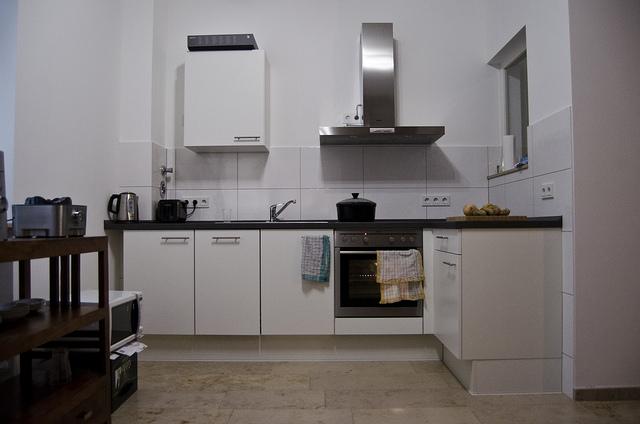Are cabinet doors open?
Keep it brief. No. Are the tiles on the floor all pointing the same direction?
Be succinct. Yes. Is the fridge in the kitchen?
Quick response, please. No. Is this a marble floor?
Give a very brief answer. No. Where is the Coffee pot?
Be succinct. Counter. Is there a door in this room?
Quick response, please. No. Is the pot on the stove?
Keep it brief. Yes. Is this an a very old home?
Give a very brief answer. No. Is it daytime?
Answer briefly. Yes. What fruits are by the sink?
Short answer required. Bananas. How many handles are visible?
Give a very brief answer. 6. Is there anything on the refrigerator door?
Concise answer only. No. What color is the table?
Write a very short answer. Brown. What type of room is this?
Concise answer only. Kitchen. What is hanging from the oven handle?
Concise answer only. Towel. Is the room empty?
Concise answer only. No. What is on the top of the knives cabinet?
Short answer required. Vcr. What is this room's function?
Quick response, please. Cooking. Where is the coffee pot?
Be succinct. Counter. Is this room clean?
Write a very short answer. Yes. Is there a refrigerator freezer in this room?
Quick response, please. No. Are these handmade cabinets?
Be succinct. No. What is on the wall?
Concise answer only. Cabinet. What is the floor made of?
Give a very brief answer. Tile. What is the appliances pictured used for?
Concise answer only. Cooking. What room is shown?
Be succinct. Kitchen. How many ovens are there?
Short answer required. 1. What is the appliance in the left corner?
Keep it brief. Microwave. Is there anything on the stove?
Quick response, please. Yes. Is this room a living room?
Keep it brief. No. Is the floor clean enough to eat off of?
Write a very short answer. Yes. There is sunlight coming in through the window?
Answer briefly. No. What type of metal does it look like they are cooking with?
Write a very short answer. Iron. What color is the wall?
Short answer required. White. What kind of appliance is on the countertop?
Write a very short answer. Toaster. Is the room carpeted?
Be succinct. No. Is this a bathroom?
Be succinct. No. What color are the cabinets?
Quick response, please. White. How many wall cabinets are there?
Answer briefly. 1. What room is this?
Answer briefly. Kitchen. Are there tulips in the vase?
Short answer required. No. Is the flooring made of marble?
Keep it brief. Yes. Is this photo taken outside?
Quick response, please. No. What color is the towel?
Quick response, please. White. Is this an old-fashioned kitchen?
Be succinct. No. How many rolls of paper are on the shelf?
Write a very short answer. 1. What color are the counters?
Give a very brief answer. Black. Is there a mirror in this photo?
Concise answer only. No. Is this a church?
Write a very short answer. No. What are the cabinets made of?
Short answer required. Wood. Is there a stove?
Be succinct. Yes. 